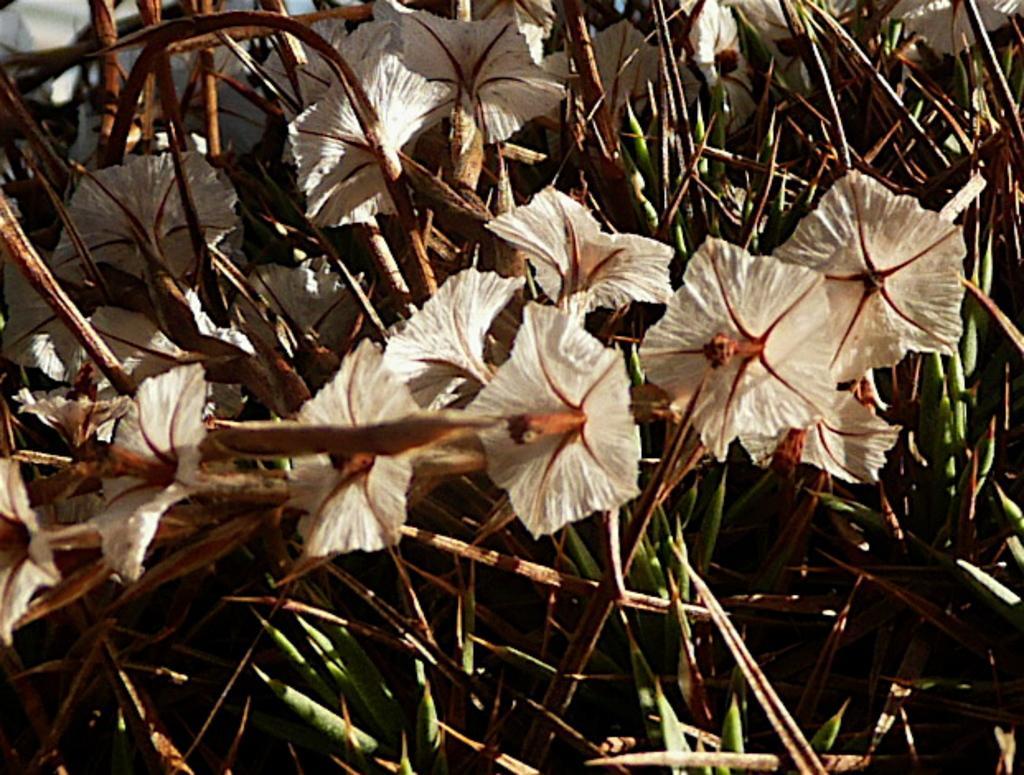Describe this image in one or two sentences. In this picture we can see white flower on the plant. At the bottom we can see the leaves. In the background there is a white color car. 